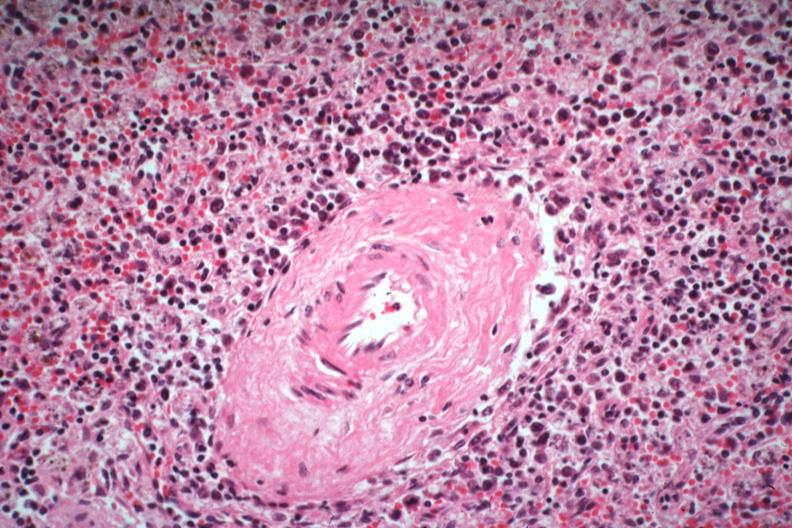s immunoblastic reaction characteristic of viral infection present?
Answer the question using a single word or phrase. Yes 